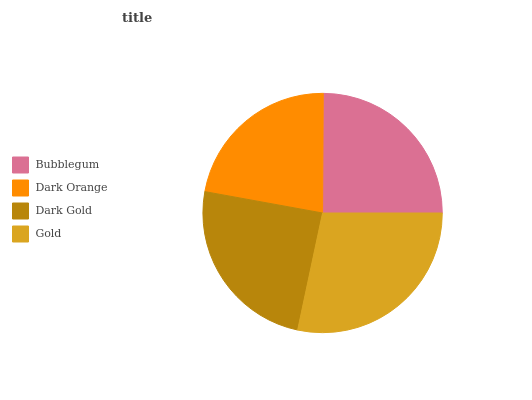Is Dark Orange the minimum?
Answer yes or no. Yes. Is Gold the maximum?
Answer yes or no. Yes. Is Dark Gold the minimum?
Answer yes or no. No. Is Dark Gold the maximum?
Answer yes or no. No. Is Dark Gold greater than Dark Orange?
Answer yes or no. Yes. Is Dark Orange less than Dark Gold?
Answer yes or no. Yes. Is Dark Orange greater than Dark Gold?
Answer yes or no. No. Is Dark Gold less than Dark Orange?
Answer yes or no. No. Is Bubblegum the high median?
Answer yes or no. Yes. Is Dark Gold the low median?
Answer yes or no. Yes. Is Gold the high median?
Answer yes or no. No. Is Gold the low median?
Answer yes or no. No. 